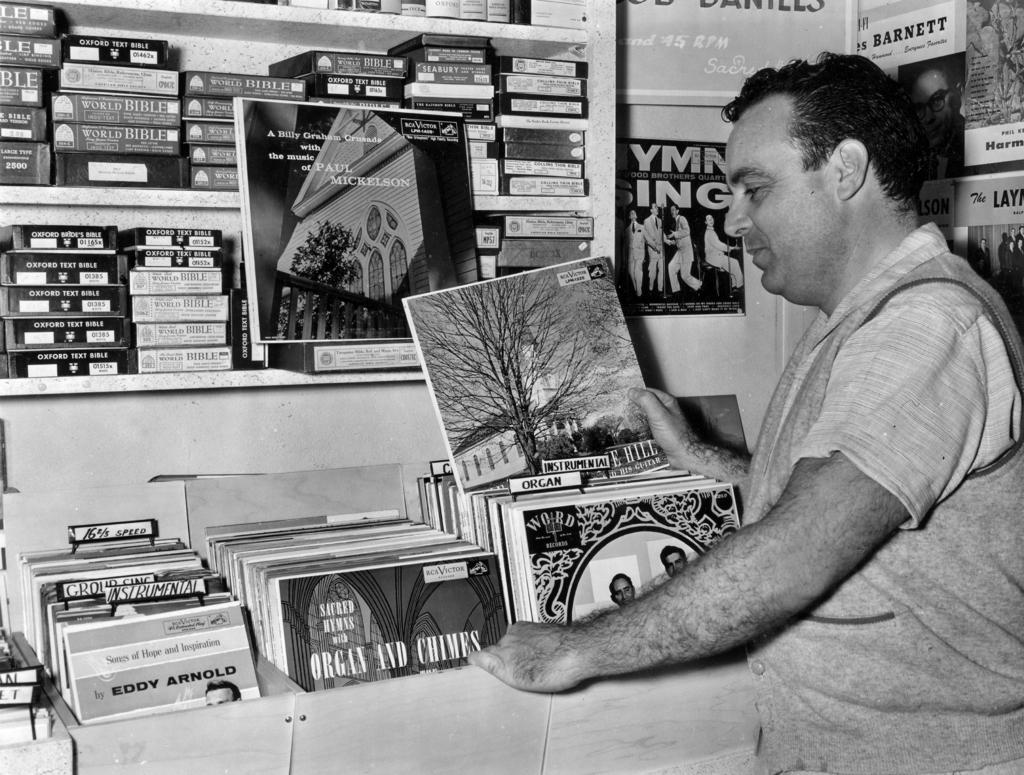What is the man in the image doing? The man is standing in the image and holding a book in his hands. What is the man holding in the image? The man is holding a book in his hands. What can be seen in the background of the image? There are many books arranged in shelves in the background of the image. Where is the girl sitting in the image? There is no girl present in the image; it only features a man standing and holding a book. 